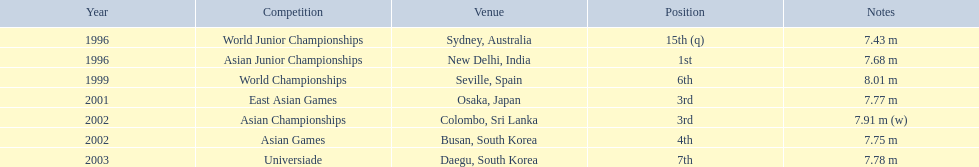What competitions did huang le compete in? World Junior Championships, Asian Junior Championships, World Championships, East Asian Games, Asian Championships, Asian Games, Universiade. What distances did he achieve in these competitions? 7.43 m, 7.68 m, 8.01 m, 7.77 m, 7.91 m (w), 7.75 m, 7.78 m. Which of these distances was the longest? 7.91 m (w). In which event did huang le attain 3rd place? East Asian Games. In which event did he reach 4th place? Asian Games. When did he achieve the top position? Asian Junior Championships. 